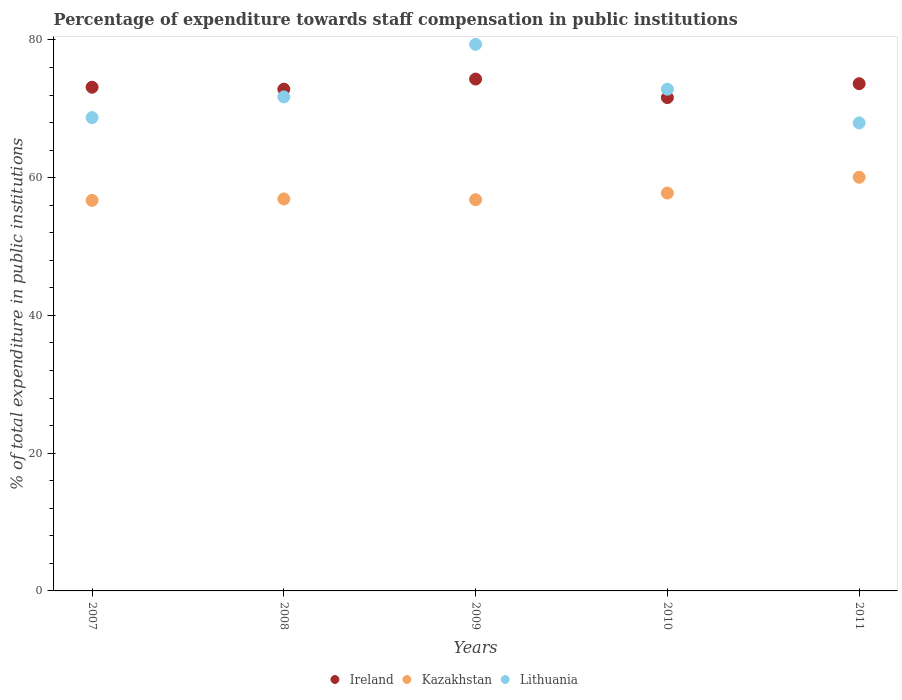How many different coloured dotlines are there?
Offer a very short reply. 3. Is the number of dotlines equal to the number of legend labels?
Keep it short and to the point. Yes. What is the percentage of expenditure towards staff compensation in Ireland in 2008?
Keep it short and to the point. 72.85. Across all years, what is the maximum percentage of expenditure towards staff compensation in Lithuania?
Keep it short and to the point. 79.36. Across all years, what is the minimum percentage of expenditure towards staff compensation in Lithuania?
Offer a terse response. 67.96. In which year was the percentage of expenditure towards staff compensation in Kazakhstan maximum?
Provide a short and direct response. 2011. In which year was the percentage of expenditure towards staff compensation in Lithuania minimum?
Offer a terse response. 2011. What is the total percentage of expenditure towards staff compensation in Ireland in the graph?
Make the answer very short. 365.59. What is the difference between the percentage of expenditure towards staff compensation in Ireland in 2009 and that in 2010?
Ensure brevity in your answer.  2.69. What is the difference between the percentage of expenditure towards staff compensation in Lithuania in 2008 and the percentage of expenditure towards staff compensation in Ireland in 2007?
Your answer should be very brief. -1.4. What is the average percentage of expenditure towards staff compensation in Ireland per year?
Make the answer very short. 73.12. In the year 2009, what is the difference between the percentage of expenditure towards staff compensation in Ireland and percentage of expenditure towards staff compensation in Lithuania?
Give a very brief answer. -5.04. What is the ratio of the percentage of expenditure towards staff compensation in Lithuania in 2007 to that in 2010?
Provide a short and direct response. 0.94. What is the difference between the highest and the second highest percentage of expenditure towards staff compensation in Lithuania?
Your response must be concise. 6.51. What is the difference between the highest and the lowest percentage of expenditure towards staff compensation in Ireland?
Offer a terse response. 2.69. In how many years, is the percentage of expenditure towards staff compensation in Lithuania greater than the average percentage of expenditure towards staff compensation in Lithuania taken over all years?
Keep it short and to the point. 2. Is it the case that in every year, the sum of the percentage of expenditure towards staff compensation in Kazakhstan and percentage of expenditure towards staff compensation in Lithuania  is greater than the percentage of expenditure towards staff compensation in Ireland?
Make the answer very short. Yes. How many dotlines are there?
Offer a terse response. 3. What is the difference between two consecutive major ticks on the Y-axis?
Ensure brevity in your answer.  20. How are the legend labels stacked?
Your answer should be compact. Horizontal. What is the title of the graph?
Your answer should be compact. Percentage of expenditure towards staff compensation in public institutions. Does "Costa Rica" appear as one of the legend labels in the graph?
Your response must be concise. No. What is the label or title of the X-axis?
Your response must be concise. Years. What is the label or title of the Y-axis?
Your answer should be very brief. % of total expenditure in public institutions. What is the % of total expenditure in public institutions in Ireland in 2007?
Offer a very short reply. 73.13. What is the % of total expenditure in public institutions of Kazakhstan in 2007?
Provide a short and direct response. 56.71. What is the % of total expenditure in public institutions in Lithuania in 2007?
Ensure brevity in your answer.  68.72. What is the % of total expenditure in public institutions in Ireland in 2008?
Offer a terse response. 72.85. What is the % of total expenditure in public institutions of Kazakhstan in 2008?
Offer a very short reply. 56.92. What is the % of total expenditure in public institutions of Lithuania in 2008?
Keep it short and to the point. 71.73. What is the % of total expenditure in public institutions in Ireland in 2009?
Make the answer very short. 74.32. What is the % of total expenditure in public institutions in Kazakhstan in 2009?
Offer a very short reply. 56.8. What is the % of total expenditure in public institutions in Lithuania in 2009?
Ensure brevity in your answer.  79.36. What is the % of total expenditure in public institutions in Ireland in 2010?
Keep it short and to the point. 71.63. What is the % of total expenditure in public institutions in Kazakhstan in 2010?
Keep it short and to the point. 57.77. What is the % of total expenditure in public institutions in Lithuania in 2010?
Your answer should be compact. 72.85. What is the % of total expenditure in public institutions of Ireland in 2011?
Make the answer very short. 73.65. What is the % of total expenditure in public institutions in Kazakhstan in 2011?
Your answer should be very brief. 60.06. What is the % of total expenditure in public institutions in Lithuania in 2011?
Ensure brevity in your answer.  67.96. Across all years, what is the maximum % of total expenditure in public institutions of Ireland?
Ensure brevity in your answer.  74.32. Across all years, what is the maximum % of total expenditure in public institutions of Kazakhstan?
Provide a succinct answer. 60.06. Across all years, what is the maximum % of total expenditure in public institutions in Lithuania?
Offer a very short reply. 79.36. Across all years, what is the minimum % of total expenditure in public institutions in Ireland?
Give a very brief answer. 71.63. Across all years, what is the minimum % of total expenditure in public institutions of Kazakhstan?
Ensure brevity in your answer.  56.71. Across all years, what is the minimum % of total expenditure in public institutions of Lithuania?
Your answer should be compact. 67.96. What is the total % of total expenditure in public institutions in Ireland in the graph?
Ensure brevity in your answer.  365.59. What is the total % of total expenditure in public institutions in Kazakhstan in the graph?
Provide a short and direct response. 288.26. What is the total % of total expenditure in public institutions of Lithuania in the graph?
Provide a short and direct response. 360.62. What is the difference between the % of total expenditure in public institutions in Ireland in 2007 and that in 2008?
Make the answer very short. 0.28. What is the difference between the % of total expenditure in public institutions of Kazakhstan in 2007 and that in 2008?
Provide a succinct answer. -0.21. What is the difference between the % of total expenditure in public institutions of Lithuania in 2007 and that in 2008?
Offer a terse response. -3.01. What is the difference between the % of total expenditure in public institutions of Ireland in 2007 and that in 2009?
Give a very brief answer. -1.19. What is the difference between the % of total expenditure in public institutions of Kazakhstan in 2007 and that in 2009?
Your response must be concise. -0.1. What is the difference between the % of total expenditure in public institutions of Lithuania in 2007 and that in 2009?
Give a very brief answer. -10.63. What is the difference between the % of total expenditure in public institutions in Ireland in 2007 and that in 2010?
Offer a terse response. 1.5. What is the difference between the % of total expenditure in public institutions in Kazakhstan in 2007 and that in 2010?
Make the answer very short. -1.06. What is the difference between the % of total expenditure in public institutions in Lithuania in 2007 and that in 2010?
Your response must be concise. -4.13. What is the difference between the % of total expenditure in public institutions in Ireland in 2007 and that in 2011?
Keep it short and to the point. -0.52. What is the difference between the % of total expenditure in public institutions in Kazakhstan in 2007 and that in 2011?
Provide a short and direct response. -3.36. What is the difference between the % of total expenditure in public institutions in Lithuania in 2007 and that in 2011?
Your answer should be compact. 0.77. What is the difference between the % of total expenditure in public institutions in Ireland in 2008 and that in 2009?
Ensure brevity in your answer.  -1.47. What is the difference between the % of total expenditure in public institutions of Kazakhstan in 2008 and that in 2009?
Your response must be concise. 0.11. What is the difference between the % of total expenditure in public institutions in Lithuania in 2008 and that in 2009?
Provide a succinct answer. -7.62. What is the difference between the % of total expenditure in public institutions in Ireland in 2008 and that in 2010?
Ensure brevity in your answer.  1.22. What is the difference between the % of total expenditure in public institutions of Kazakhstan in 2008 and that in 2010?
Ensure brevity in your answer.  -0.85. What is the difference between the % of total expenditure in public institutions in Lithuania in 2008 and that in 2010?
Give a very brief answer. -1.12. What is the difference between the % of total expenditure in public institutions of Ireland in 2008 and that in 2011?
Give a very brief answer. -0.8. What is the difference between the % of total expenditure in public institutions in Kazakhstan in 2008 and that in 2011?
Your answer should be compact. -3.15. What is the difference between the % of total expenditure in public institutions in Lithuania in 2008 and that in 2011?
Offer a terse response. 3.78. What is the difference between the % of total expenditure in public institutions in Ireland in 2009 and that in 2010?
Your answer should be compact. 2.69. What is the difference between the % of total expenditure in public institutions of Kazakhstan in 2009 and that in 2010?
Offer a terse response. -0.97. What is the difference between the % of total expenditure in public institutions in Lithuania in 2009 and that in 2010?
Ensure brevity in your answer.  6.51. What is the difference between the % of total expenditure in public institutions of Ireland in 2009 and that in 2011?
Provide a succinct answer. 0.67. What is the difference between the % of total expenditure in public institutions of Kazakhstan in 2009 and that in 2011?
Offer a very short reply. -3.26. What is the difference between the % of total expenditure in public institutions in Lithuania in 2009 and that in 2011?
Your response must be concise. 11.4. What is the difference between the % of total expenditure in public institutions of Ireland in 2010 and that in 2011?
Keep it short and to the point. -2.02. What is the difference between the % of total expenditure in public institutions in Kazakhstan in 2010 and that in 2011?
Provide a short and direct response. -2.29. What is the difference between the % of total expenditure in public institutions in Lithuania in 2010 and that in 2011?
Provide a succinct answer. 4.89. What is the difference between the % of total expenditure in public institutions of Ireland in 2007 and the % of total expenditure in public institutions of Kazakhstan in 2008?
Make the answer very short. 16.22. What is the difference between the % of total expenditure in public institutions in Ireland in 2007 and the % of total expenditure in public institutions in Lithuania in 2008?
Offer a very short reply. 1.4. What is the difference between the % of total expenditure in public institutions of Kazakhstan in 2007 and the % of total expenditure in public institutions of Lithuania in 2008?
Give a very brief answer. -15.03. What is the difference between the % of total expenditure in public institutions in Ireland in 2007 and the % of total expenditure in public institutions in Kazakhstan in 2009?
Your answer should be compact. 16.33. What is the difference between the % of total expenditure in public institutions of Ireland in 2007 and the % of total expenditure in public institutions of Lithuania in 2009?
Provide a succinct answer. -6.22. What is the difference between the % of total expenditure in public institutions in Kazakhstan in 2007 and the % of total expenditure in public institutions in Lithuania in 2009?
Your answer should be compact. -22.65. What is the difference between the % of total expenditure in public institutions of Ireland in 2007 and the % of total expenditure in public institutions of Kazakhstan in 2010?
Your response must be concise. 15.36. What is the difference between the % of total expenditure in public institutions in Ireland in 2007 and the % of total expenditure in public institutions in Lithuania in 2010?
Provide a short and direct response. 0.28. What is the difference between the % of total expenditure in public institutions of Kazakhstan in 2007 and the % of total expenditure in public institutions of Lithuania in 2010?
Your response must be concise. -16.14. What is the difference between the % of total expenditure in public institutions of Ireland in 2007 and the % of total expenditure in public institutions of Kazakhstan in 2011?
Make the answer very short. 13.07. What is the difference between the % of total expenditure in public institutions in Ireland in 2007 and the % of total expenditure in public institutions in Lithuania in 2011?
Provide a succinct answer. 5.18. What is the difference between the % of total expenditure in public institutions in Kazakhstan in 2007 and the % of total expenditure in public institutions in Lithuania in 2011?
Your answer should be compact. -11.25. What is the difference between the % of total expenditure in public institutions of Ireland in 2008 and the % of total expenditure in public institutions of Kazakhstan in 2009?
Your answer should be very brief. 16.05. What is the difference between the % of total expenditure in public institutions in Ireland in 2008 and the % of total expenditure in public institutions in Lithuania in 2009?
Your answer should be compact. -6.51. What is the difference between the % of total expenditure in public institutions of Kazakhstan in 2008 and the % of total expenditure in public institutions of Lithuania in 2009?
Your answer should be very brief. -22.44. What is the difference between the % of total expenditure in public institutions of Ireland in 2008 and the % of total expenditure in public institutions of Kazakhstan in 2010?
Offer a terse response. 15.08. What is the difference between the % of total expenditure in public institutions in Ireland in 2008 and the % of total expenditure in public institutions in Lithuania in 2010?
Keep it short and to the point. 0. What is the difference between the % of total expenditure in public institutions in Kazakhstan in 2008 and the % of total expenditure in public institutions in Lithuania in 2010?
Your answer should be very brief. -15.93. What is the difference between the % of total expenditure in public institutions of Ireland in 2008 and the % of total expenditure in public institutions of Kazakhstan in 2011?
Offer a terse response. 12.79. What is the difference between the % of total expenditure in public institutions in Ireland in 2008 and the % of total expenditure in public institutions in Lithuania in 2011?
Your answer should be very brief. 4.9. What is the difference between the % of total expenditure in public institutions in Kazakhstan in 2008 and the % of total expenditure in public institutions in Lithuania in 2011?
Give a very brief answer. -11.04. What is the difference between the % of total expenditure in public institutions of Ireland in 2009 and the % of total expenditure in public institutions of Kazakhstan in 2010?
Give a very brief answer. 16.55. What is the difference between the % of total expenditure in public institutions in Ireland in 2009 and the % of total expenditure in public institutions in Lithuania in 2010?
Give a very brief answer. 1.47. What is the difference between the % of total expenditure in public institutions of Kazakhstan in 2009 and the % of total expenditure in public institutions of Lithuania in 2010?
Keep it short and to the point. -16.05. What is the difference between the % of total expenditure in public institutions of Ireland in 2009 and the % of total expenditure in public institutions of Kazakhstan in 2011?
Provide a succinct answer. 14.26. What is the difference between the % of total expenditure in public institutions of Ireland in 2009 and the % of total expenditure in public institutions of Lithuania in 2011?
Offer a very short reply. 6.37. What is the difference between the % of total expenditure in public institutions in Kazakhstan in 2009 and the % of total expenditure in public institutions in Lithuania in 2011?
Your answer should be compact. -11.15. What is the difference between the % of total expenditure in public institutions in Ireland in 2010 and the % of total expenditure in public institutions in Kazakhstan in 2011?
Give a very brief answer. 11.57. What is the difference between the % of total expenditure in public institutions in Ireland in 2010 and the % of total expenditure in public institutions in Lithuania in 2011?
Make the answer very short. 3.67. What is the difference between the % of total expenditure in public institutions of Kazakhstan in 2010 and the % of total expenditure in public institutions of Lithuania in 2011?
Provide a succinct answer. -10.19. What is the average % of total expenditure in public institutions in Ireland per year?
Give a very brief answer. 73.12. What is the average % of total expenditure in public institutions in Kazakhstan per year?
Your answer should be very brief. 57.65. What is the average % of total expenditure in public institutions in Lithuania per year?
Your answer should be compact. 72.12. In the year 2007, what is the difference between the % of total expenditure in public institutions in Ireland and % of total expenditure in public institutions in Kazakhstan?
Keep it short and to the point. 16.43. In the year 2007, what is the difference between the % of total expenditure in public institutions of Ireland and % of total expenditure in public institutions of Lithuania?
Your answer should be compact. 4.41. In the year 2007, what is the difference between the % of total expenditure in public institutions in Kazakhstan and % of total expenditure in public institutions in Lithuania?
Your answer should be very brief. -12.02. In the year 2008, what is the difference between the % of total expenditure in public institutions in Ireland and % of total expenditure in public institutions in Kazakhstan?
Offer a very short reply. 15.94. In the year 2008, what is the difference between the % of total expenditure in public institutions of Ireland and % of total expenditure in public institutions of Lithuania?
Your response must be concise. 1.12. In the year 2008, what is the difference between the % of total expenditure in public institutions of Kazakhstan and % of total expenditure in public institutions of Lithuania?
Keep it short and to the point. -14.82. In the year 2009, what is the difference between the % of total expenditure in public institutions of Ireland and % of total expenditure in public institutions of Kazakhstan?
Your answer should be very brief. 17.52. In the year 2009, what is the difference between the % of total expenditure in public institutions in Ireland and % of total expenditure in public institutions in Lithuania?
Make the answer very short. -5.04. In the year 2009, what is the difference between the % of total expenditure in public institutions in Kazakhstan and % of total expenditure in public institutions in Lithuania?
Ensure brevity in your answer.  -22.56. In the year 2010, what is the difference between the % of total expenditure in public institutions in Ireland and % of total expenditure in public institutions in Kazakhstan?
Provide a succinct answer. 13.86. In the year 2010, what is the difference between the % of total expenditure in public institutions in Ireland and % of total expenditure in public institutions in Lithuania?
Ensure brevity in your answer.  -1.22. In the year 2010, what is the difference between the % of total expenditure in public institutions in Kazakhstan and % of total expenditure in public institutions in Lithuania?
Give a very brief answer. -15.08. In the year 2011, what is the difference between the % of total expenditure in public institutions in Ireland and % of total expenditure in public institutions in Kazakhstan?
Offer a very short reply. 13.59. In the year 2011, what is the difference between the % of total expenditure in public institutions in Ireland and % of total expenditure in public institutions in Lithuania?
Provide a succinct answer. 5.7. In the year 2011, what is the difference between the % of total expenditure in public institutions in Kazakhstan and % of total expenditure in public institutions in Lithuania?
Your answer should be very brief. -7.89. What is the ratio of the % of total expenditure in public institutions of Kazakhstan in 2007 to that in 2008?
Offer a very short reply. 1. What is the ratio of the % of total expenditure in public institutions in Lithuania in 2007 to that in 2008?
Keep it short and to the point. 0.96. What is the ratio of the % of total expenditure in public institutions of Kazakhstan in 2007 to that in 2009?
Your answer should be very brief. 1. What is the ratio of the % of total expenditure in public institutions of Lithuania in 2007 to that in 2009?
Make the answer very short. 0.87. What is the ratio of the % of total expenditure in public institutions in Kazakhstan in 2007 to that in 2010?
Provide a short and direct response. 0.98. What is the ratio of the % of total expenditure in public institutions of Lithuania in 2007 to that in 2010?
Ensure brevity in your answer.  0.94. What is the ratio of the % of total expenditure in public institutions of Ireland in 2007 to that in 2011?
Provide a succinct answer. 0.99. What is the ratio of the % of total expenditure in public institutions in Kazakhstan in 2007 to that in 2011?
Your response must be concise. 0.94. What is the ratio of the % of total expenditure in public institutions in Lithuania in 2007 to that in 2011?
Your answer should be very brief. 1.01. What is the ratio of the % of total expenditure in public institutions in Ireland in 2008 to that in 2009?
Your response must be concise. 0.98. What is the ratio of the % of total expenditure in public institutions of Kazakhstan in 2008 to that in 2009?
Offer a very short reply. 1. What is the ratio of the % of total expenditure in public institutions of Lithuania in 2008 to that in 2009?
Provide a short and direct response. 0.9. What is the ratio of the % of total expenditure in public institutions of Ireland in 2008 to that in 2010?
Make the answer very short. 1.02. What is the ratio of the % of total expenditure in public institutions of Kazakhstan in 2008 to that in 2010?
Your answer should be very brief. 0.99. What is the ratio of the % of total expenditure in public institutions of Lithuania in 2008 to that in 2010?
Your answer should be compact. 0.98. What is the ratio of the % of total expenditure in public institutions of Ireland in 2008 to that in 2011?
Your answer should be very brief. 0.99. What is the ratio of the % of total expenditure in public institutions of Kazakhstan in 2008 to that in 2011?
Make the answer very short. 0.95. What is the ratio of the % of total expenditure in public institutions of Lithuania in 2008 to that in 2011?
Your answer should be very brief. 1.06. What is the ratio of the % of total expenditure in public institutions in Ireland in 2009 to that in 2010?
Offer a very short reply. 1.04. What is the ratio of the % of total expenditure in public institutions in Kazakhstan in 2009 to that in 2010?
Ensure brevity in your answer.  0.98. What is the ratio of the % of total expenditure in public institutions in Lithuania in 2009 to that in 2010?
Keep it short and to the point. 1.09. What is the ratio of the % of total expenditure in public institutions in Ireland in 2009 to that in 2011?
Provide a succinct answer. 1.01. What is the ratio of the % of total expenditure in public institutions of Kazakhstan in 2009 to that in 2011?
Offer a very short reply. 0.95. What is the ratio of the % of total expenditure in public institutions of Lithuania in 2009 to that in 2011?
Your answer should be very brief. 1.17. What is the ratio of the % of total expenditure in public institutions in Ireland in 2010 to that in 2011?
Provide a succinct answer. 0.97. What is the ratio of the % of total expenditure in public institutions of Kazakhstan in 2010 to that in 2011?
Ensure brevity in your answer.  0.96. What is the ratio of the % of total expenditure in public institutions in Lithuania in 2010 to that in 2011?
Make the answer very short. 1.07. What is the difference between the highest and the second highest % of total expenditure in public institutions of Ireland?
Provide a short and direct response. 0.67. What is the difference between the highest and the second highest % of total expenditure in public institutions of Kazakhstan?
Your answer should be compact. 2.29. What is the difference between the highest and the second highest % of total expenditure in public institutions of Lithuania?
Provide a succinct answer. 6.51. What is the difference between the highest and the lowest % of total expenditure in public institutions of Ireland?
Provide a succinct answer. 2.69. What is the difference between the highest and the lowest % of total expenditure in public institutions in Kazakhstan?
Your answer should be very brief. 3.36. What is the difference between the highest and the lowest % of total expenditure in public institutions of Lithuania?
Offer a very short reply. 11.4. 